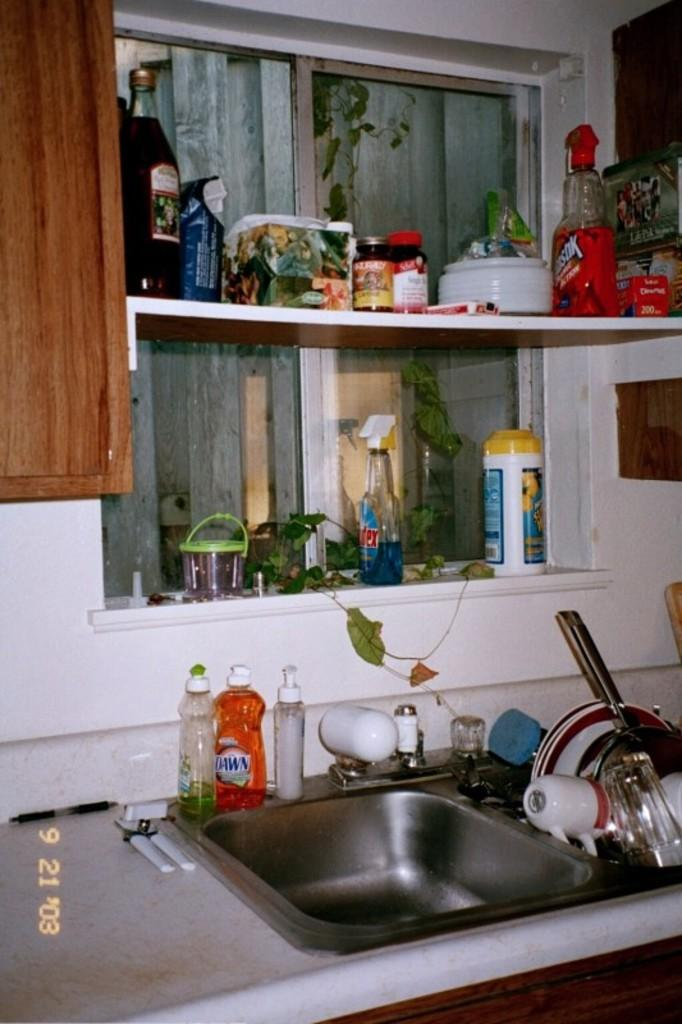What is the main object in the image? There is a sink in the image. What is placed on the sink? There are bottles on the sink. Are there any other objects on the sink besides the bottles? Yes, there are other objects on the sink. How many girls are climbing the tree in the image? There is no tree or girl present in the image. What type of heart-shaped object can be seen in the image? There is no heart-shaped object present in the image. 